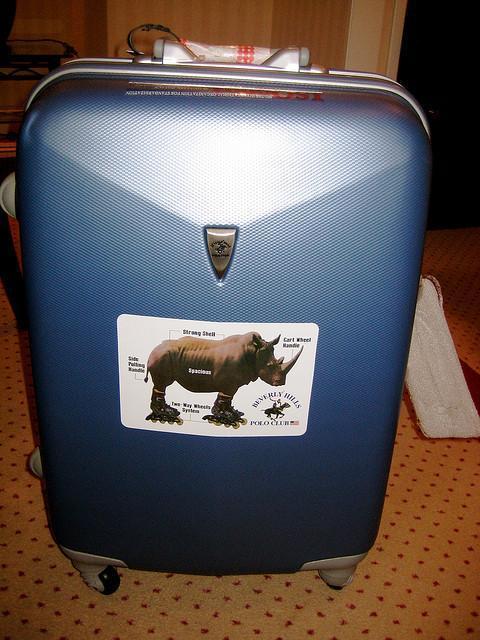How many elephants are in the scene?
Give a very brief answer. 0. 